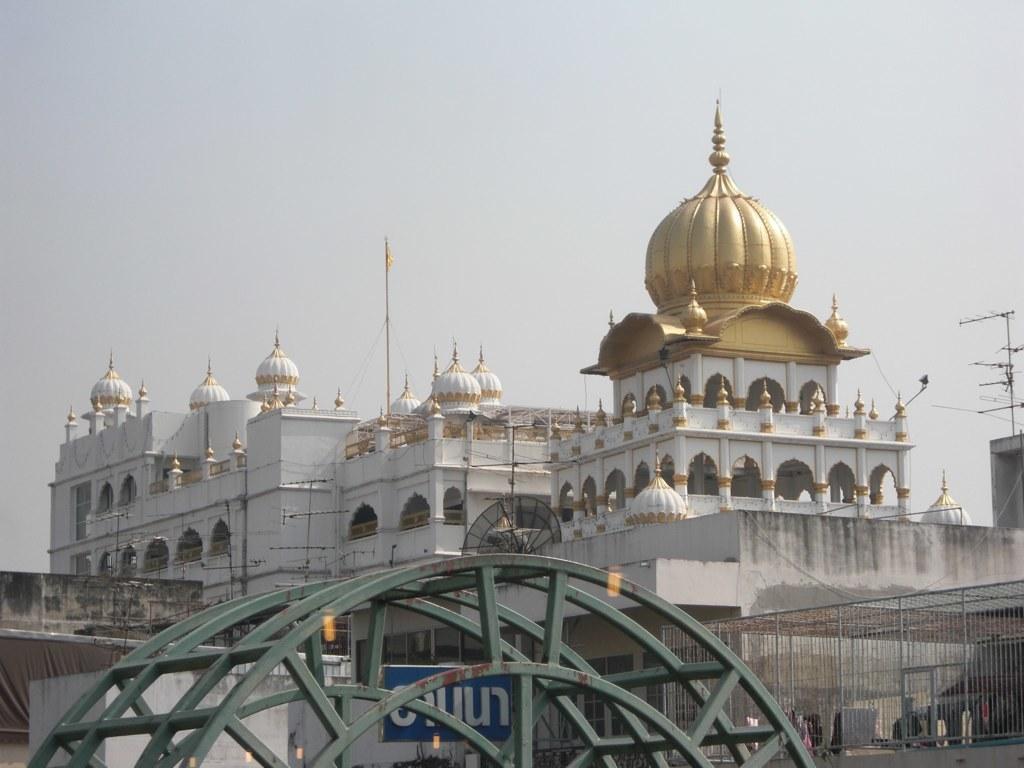Could you give a brief overview of what you see in this image? In this image I can see a huge metal structure and few buildings. I can see the metal railing, few antennas on the buildings and in the background I can see the sky. 